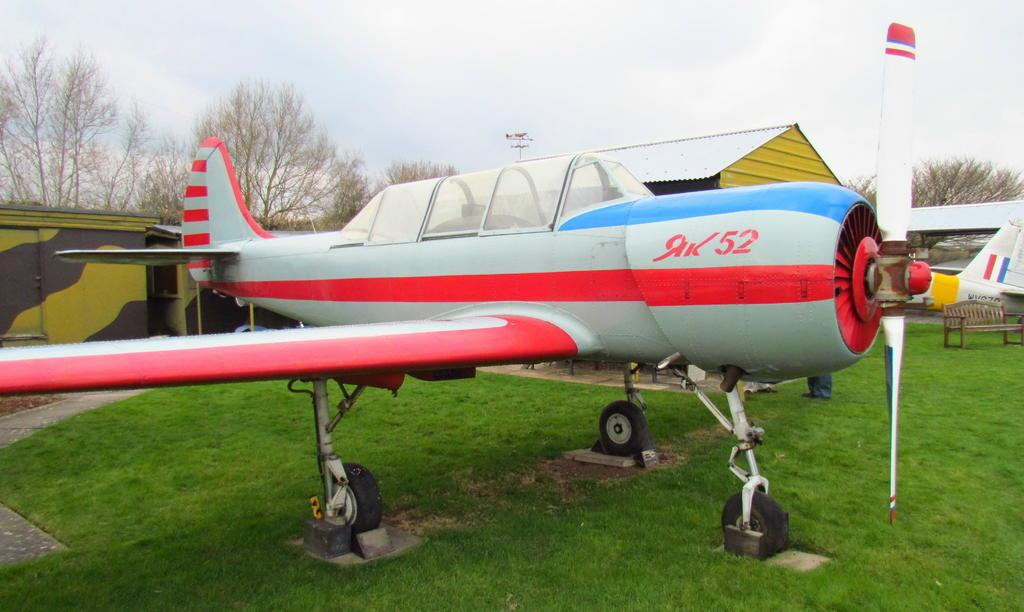<image>
Create a compact narrative representing the image presented. a red and blue stiped plane with number 52 on it parked on a lawn 